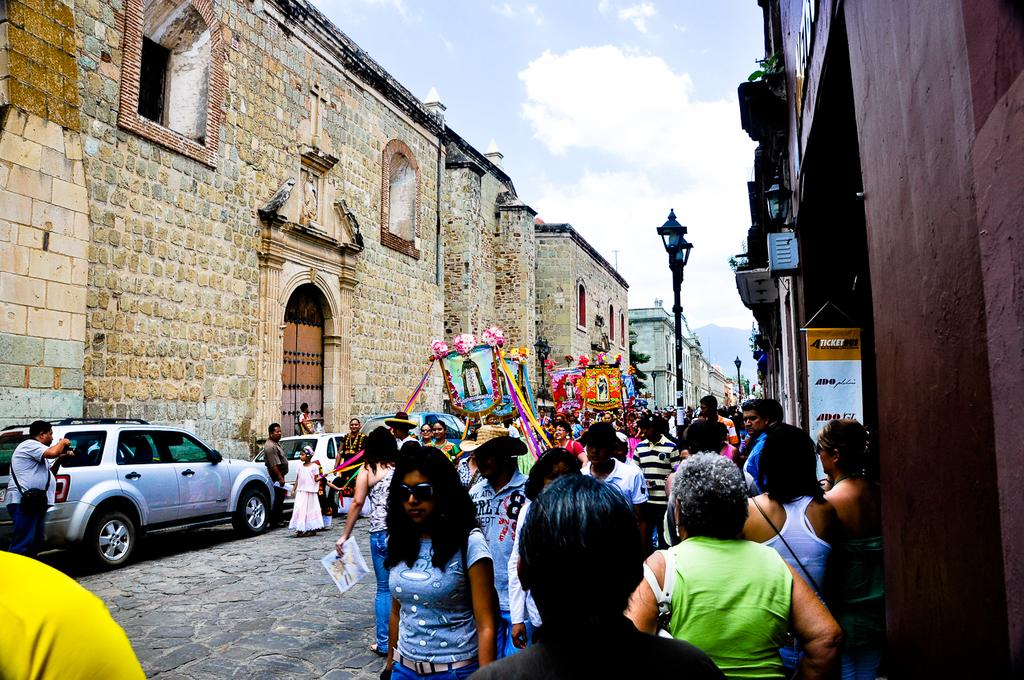Who or what can be seen in the image? There are people in the image. What else is present in the image besides people? There are vehicles on the road, lights, poles, a banner, colorful objects, buildings, windows, and the sky with clouds is visible in the background. Can you describe the vehicles in the image? The vehicles on the road are not specified, but they are present in the image. What type of buildings can be seen in the image? The buildings in the image are not specified, but they are present. How many elements can be seen in the sky? The sky has clouds visible in the background. Can you tell me how many fans are visible in the image? There are no fans present in the image. What type of basket is being used by the people in the image? There is no basket present in the image. 